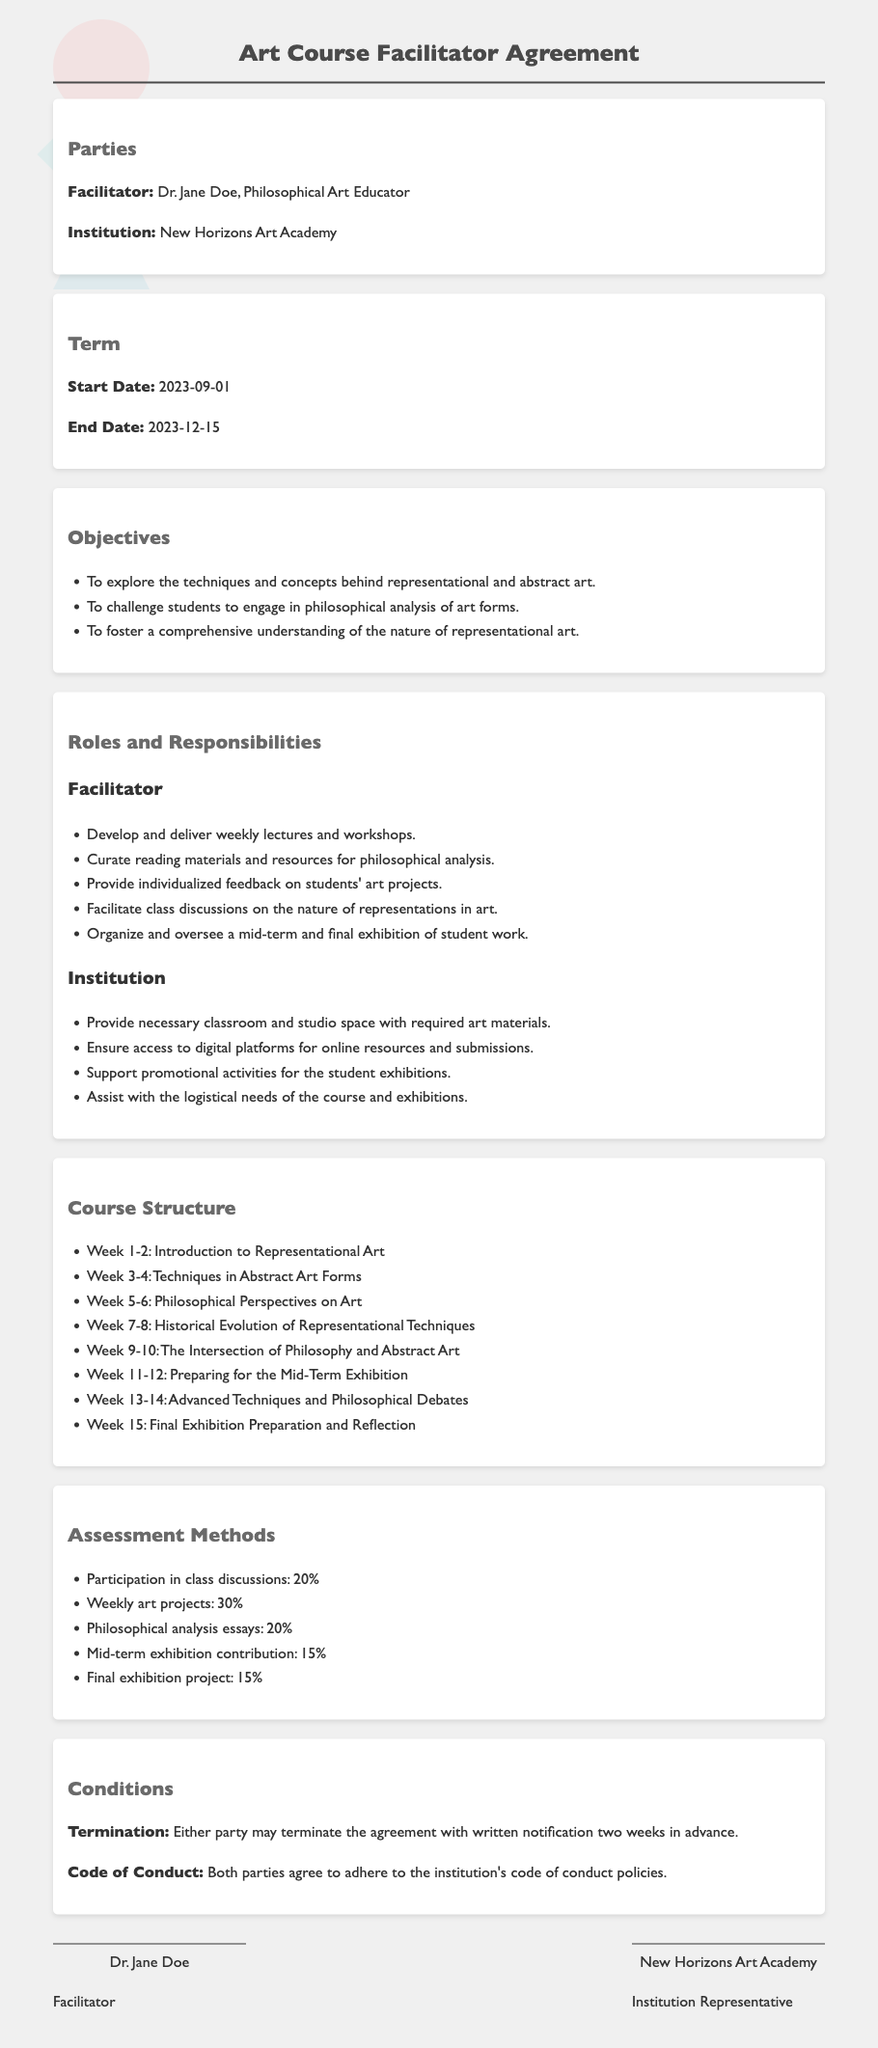What is the name of the facilitator? The document states that the facilitator is Dr. Jane Doe.
Answer: Dr. Jane Doe What is the start date of the course? According to the document, the start date is specified as September 1, 2023.
Answer: 2023-09-01 What percentage of the assessment is based on participation in class discussions? The document outlines that participation in class discussions accounts for 20% of the assessment.
Answer: 20% How many weeks are dedicated to preparing for the mid-term exhibition? The course structure indicates that two weeks are specifically for preparing the mid-term exhibition.
Answer: 2 weeks What are the responsibilities of the facilitator? The document lists several responsibilities including developing and delivering lectures, which are among the roles mentioned for the facilitator.
Answer: Develop and deliver weekly lectures and workshops What is the end date of the contract? The document specifies that the end date of the course is December 15, 2023.
Answer: 2023-12-15 What is the main emphasis of the art course? The document states that the course emphasizes philosophical analysis, alongside representational and abstract art techniques.
Answer: Philosophical analysis What must both parties adhere to? The contract states that both parties agree to adhere to the institution's code of conduct policies.
Answer: Code of conduct How many weeks are dedicated to the intersection of philosophy and abstract art? The document indicates that two weeks are allocated to this topic in the course structure.
Answer: 2 weeks 